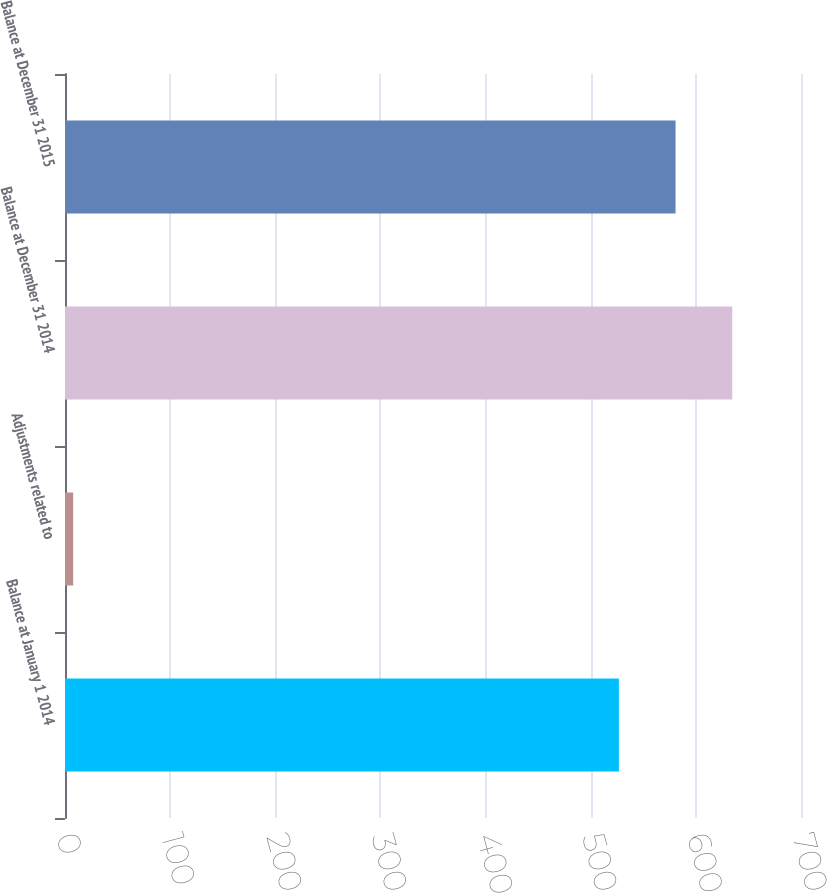Convert chart to OTSL. <chart><loc_0><loc_0><loc_500><loc_500><bar_chart><fcel>Balance at January 1 2014<fcel>Adjustments related to<fcel>Balance at December 31 2014<fcel>Balance at December 31 2015<nl><fcel>526.8<fcel>7.8<fcel>634.6<fcel>580.7<nl></chart> 